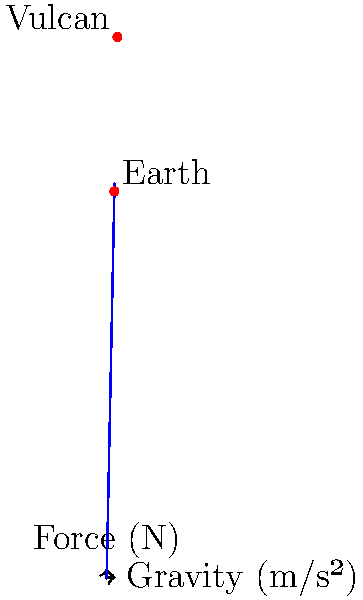In the Star Trek universe, Vulcans evolved on a planet with 1.4 times Earth's gravity. If a 50 kg Vulcan visits Earth, how much less force (in Newtons) would they experience on their skeletal structure compared to their home planet? Let's approach this step-by-step:

1) First, we need to calculate the force experienced by the Vulcan on their home planet:
   - Gravity on Vulcan = 1.4 * Earth's gravity
   - Earth's gravity = 9.8 m/s²
   - Vulcan's gravity = 1.4 * 9.8 = 13.72 m/s²
   - Force on Vulcan = mass * gravity = 50 kg * 13.72 m/s² = 686 N

2) Now, let's calculate the force experienced by the Vulcan on Earth:
   - Earth's gravity = 9.8 m/s²
   - Force on Earth = mass * gravity = 50 kg * 9.8 m/s² = 490 N

3) To find how much less force they experience on Earth, we subtract:
   Difference in force = Force on Vulcan - Force on Earth
                       = 686 N - 490 N
                       = 196 N

Therefore, the Vulcan would experience 196 N less force on their skeletal structure on Earth compared to their home planet.
Answer: 196 N 